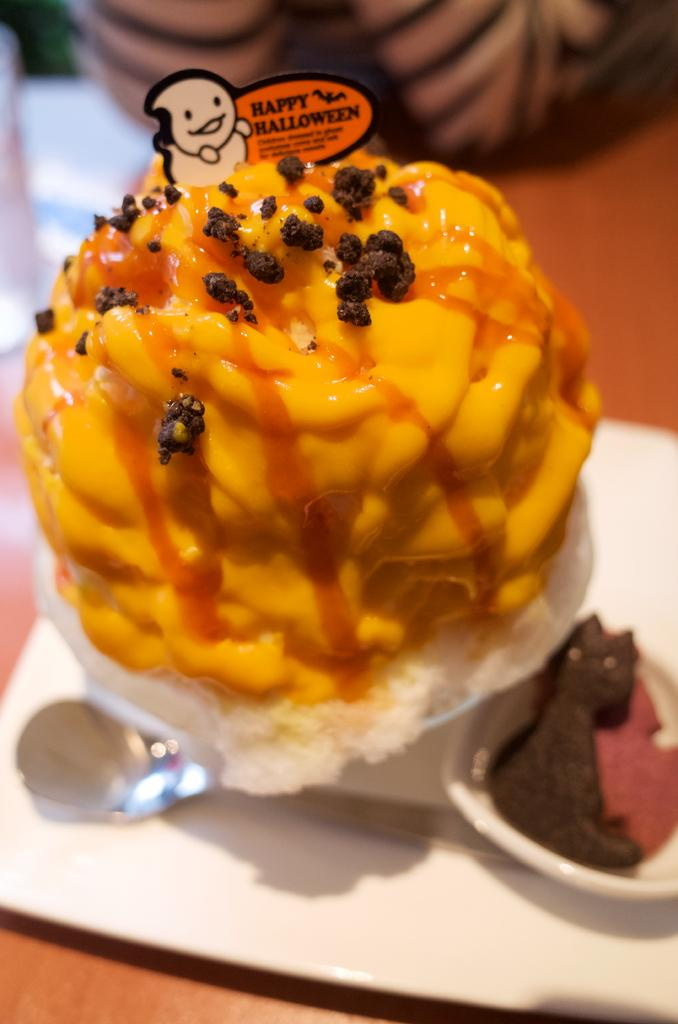What is the main object in the image? There is a table in the image. What is placed on the table? There are ice creams on the table. What utensil is present on the table? There is a spoon on the table. Can you describe the background of the image? The background of the image is blurred. How many cats can be seen looking at the ice creams in the image? There are no cats present in the image. 